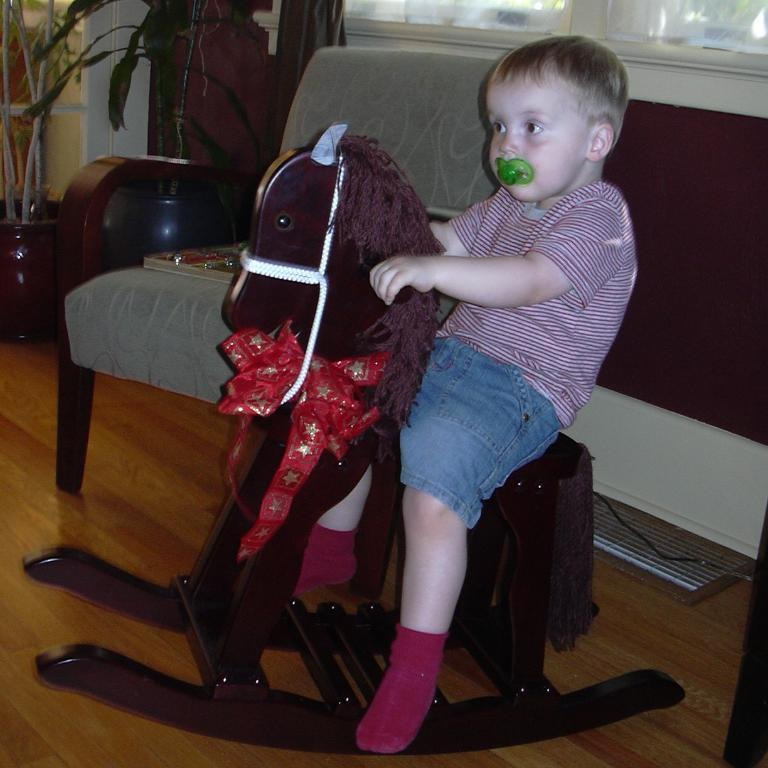What is the main subject of the image? There is a boy in the image. What is the boy doing in the image? The boy is sitting on a horse toy. Can you describe what the boy has in his mouth? The boy has something in his mouth, but it is not specified what it is. What type of airplane is the boy flying in the image? There is no airplane present in the image; the boy is sitting on a horse toy. What does the taste of the object in the boy's mouth suggest about its flavor? We cannot determine the taste of the object in the boy's mouth from the image, as it is not specified what it is. 